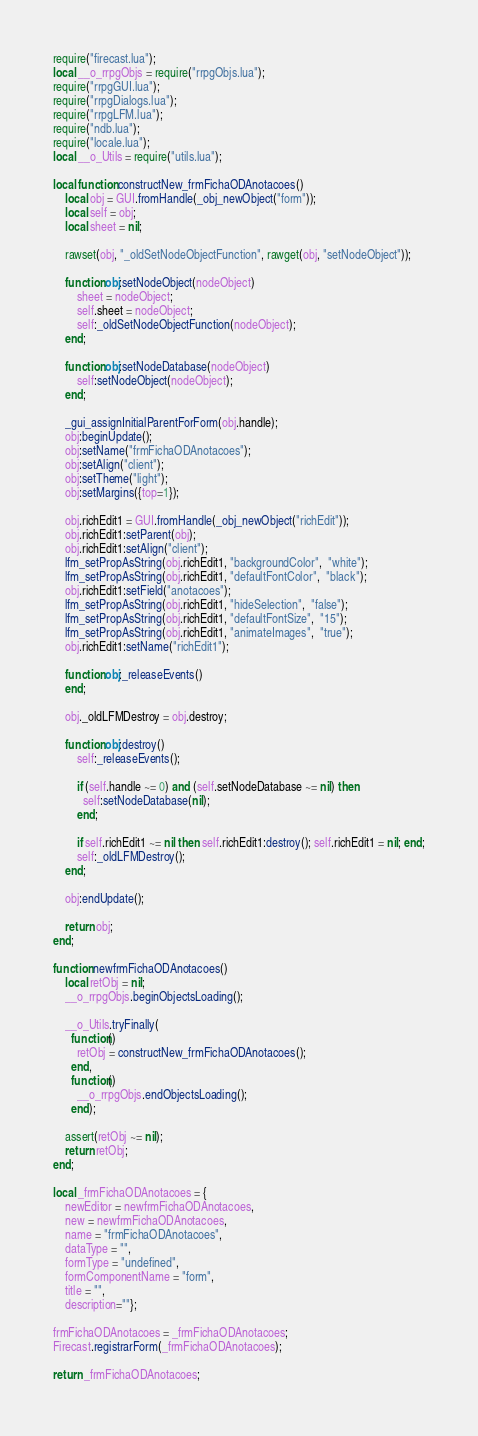<code> <loc_0><loc_0><loc_500><loc_500><_Lua_>require("firecast.lua");
local __o_rrpgObjs = require("rrpgObjs.lua");
require("rrpgGUI.lua");
require("rrpgDialogs.lua");
require("rrpgLFM.lua");
require("ndb.lua");
require("locale.lua");
local __o_Utils = require("utils.lua");

local function constructNew_frmFichaODAnotacoes()
    local obj = GUI.fromHandle(_obj_newObject("form"));
    local self = obj;
    local sheet = nil;

    rawset(obj, "_oldSetNodeObjectFunction", rawget(obj, "setNodeObject"));

    function obj:setNodeObject(nodeObject)
        sheet = nodeObject;
        self.sheet = nodeObject;
        self:_oldSetNodeObjectFunction(nodeObject);
    end;

    function obj:setNodeDatabase(nodeObject)
        self:setNodeObject(nodeObject);
    end;

    _gui_assignInitialParentForForm(obj.handle);
    obj:beginUpdate();
    obj:setName("frmFichaODAnotacoes");
    obj:setAlign("client");
    obj:setTheme("light");
    obj:setMargins({top=1});

    obj.richEdit1 = GUI.fromHandle(_obj_newObject("richEdit"));
    obj.richEdit1:setParent(obj);
    obj.richEdit1:setAlign("client");
    lfm_setPropAsString(obj.richEdit1, "backgroundColor",  "white");
    lfm_setPropAsString(obj.richEdit1, "defaultFontColor",  "black");
    obj.richEdit1:setField("anotacoes");
    lfm_setPropAsString(obj.richEdit1, "hideSelection",  "false");
    lfm_setPropAsString(obj.richEdit1, "defaultFontSize",  "15");
    lfm_setPropAsString(obj.richEdit1, "animateImages",  "true");
    obj.richEdit1:setName("richEdit1");

    function obj:_releaseEvents()
    end;

    obj._oldLFMDestroy = obj.destroy;

    function obj:destroy() 
        self:_releaseEvents();

        if (self.handle ~= 0) and (self.setNodeDatabase ~= nil) then
          self:setNodeDatabase(nil);
        end;

        if self.richEdit1 ~= nil then self.richEdit1:destroy(); self.richEdit1 = nil; end;
        self:_oldLFMDestroy();
    end;

    obj:endUpdate();

    return obj;
end;

function newfrmFichaODAnotacoes()
    local retObj = nil;
    __o_rrpgObjs.beginObjectsLoading();

    __o_Utils.tryFinally(
      function()
        retObj = constructNew_frmFichaODAnotacoes();
      end,
      function()
        __o_rrpgObjs.endObjectsLoading();
      end);

    assert(retObj ~= nil);
    return retObj;
end;

local _frmFichaODAnotacoes = {
    newEditor = newfrmFichaODAnotacoes, 
    new = newfrmFichaODAnotacoes, 
    name = "frmFichaODAnotacoes", 
    dataType = "", 
    formType = "undefined", 
    formComponentName = "form", 
    title = "", 
    description=""};

frmFichaODAnotacoes = _frmFichaODAnotacoes;
Firecast.registrarForm(_frmFichaODAnotacoes);

return _frmFichaODAnotacoes;
</code> 